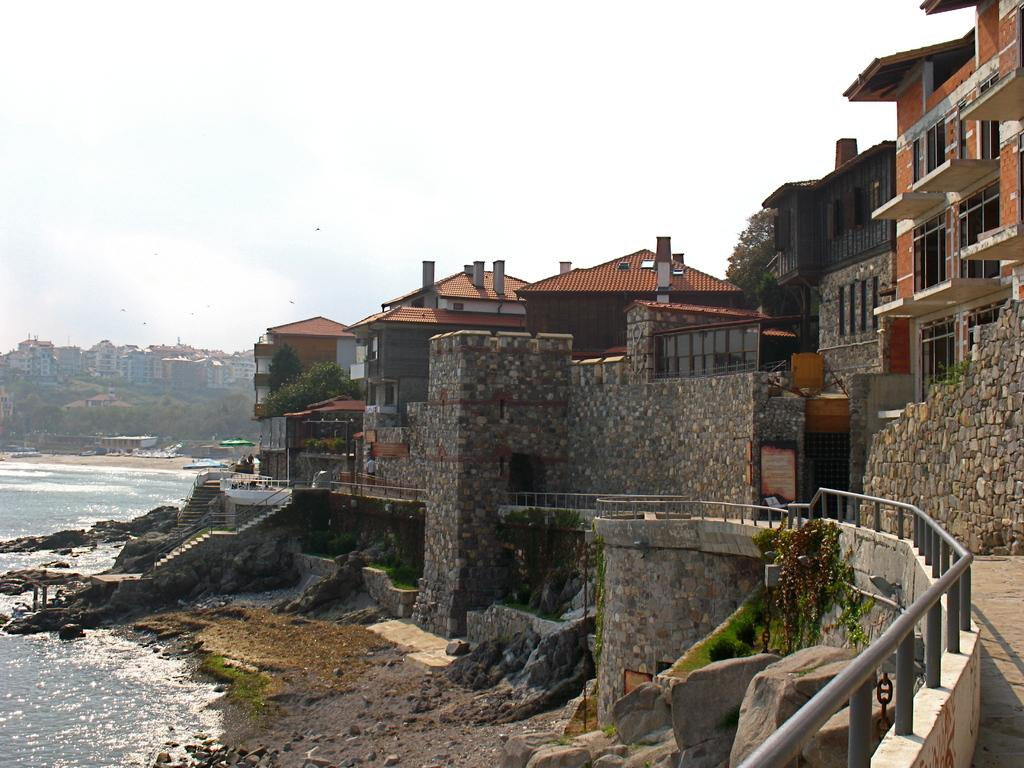What is located in the foreground of the image? In the foreground of the image, there is a railing, a path, rocks, land, water, and buildings. Can you describe the terrain in the foreground of the image? The terrain in the foreground of the image includes rocks, land, and water. What is visible in the background of the image? In the background of the image, there are buildings, trees, water, birds, and the sky. How many types of structures can be seen in the image? There are buildings visible in both the foreground and background of the image. What type of wildlife can be seen in the image? Birds are visible in the background of the image. Where is the wrench being used in the image? There is no wrench present in the image. How many mice are visible in the image? There are no mice visible in the image. 